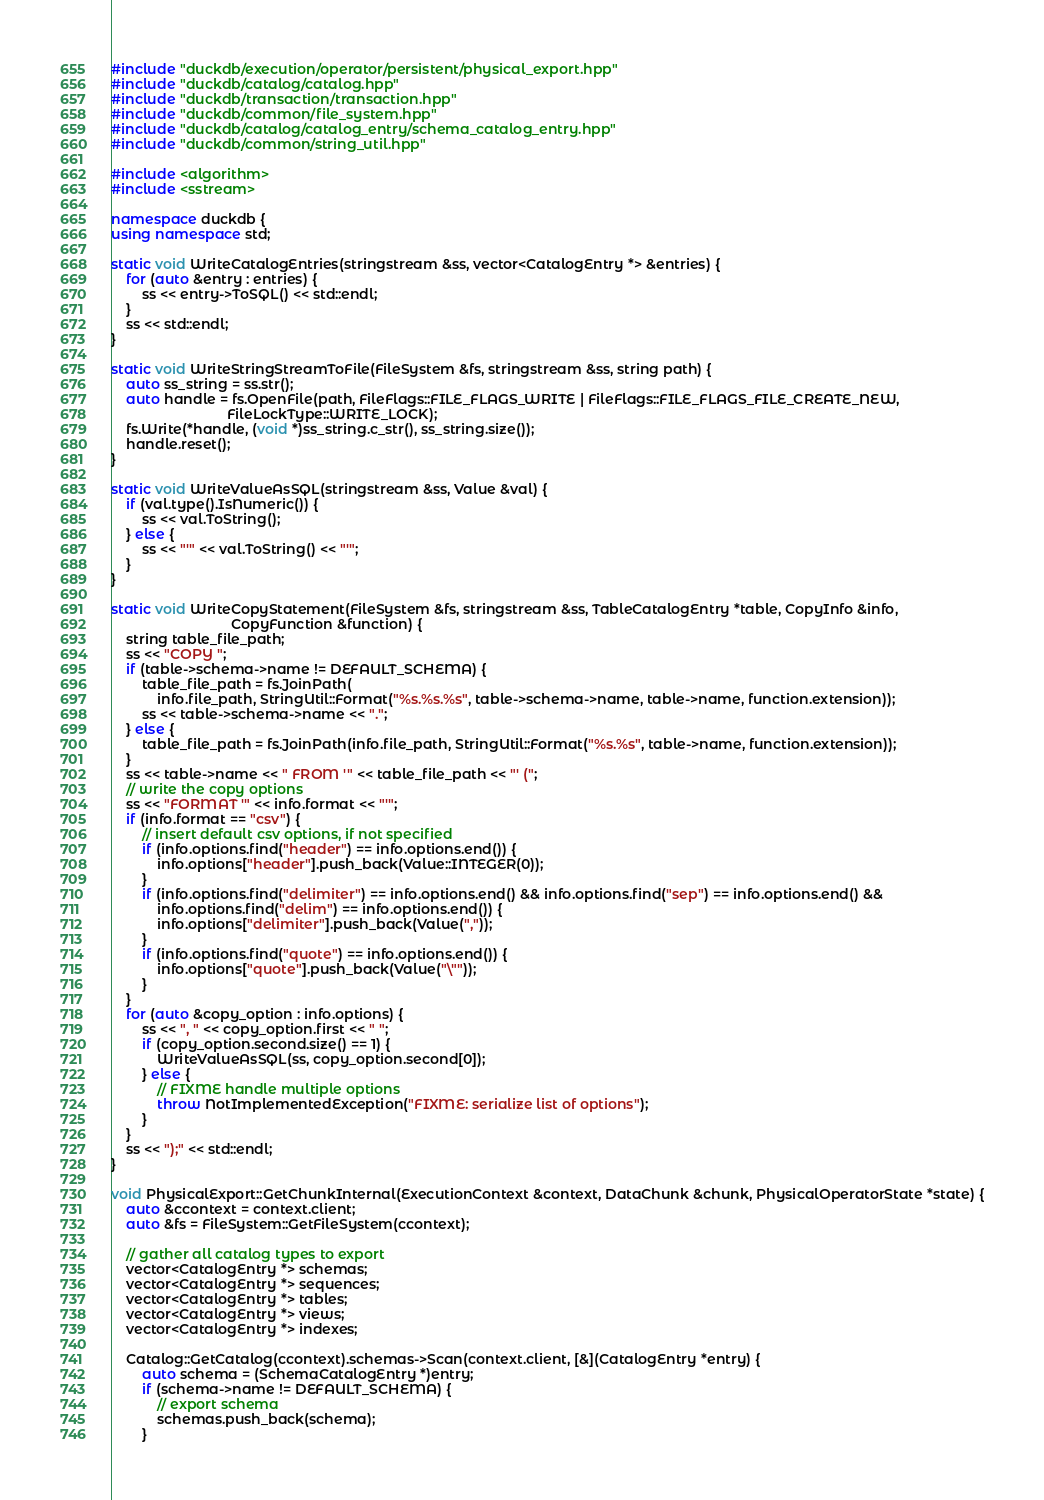Convert code to text. <code><loc_0><loc_0><loc_500><loc_500><_C++_>#include "duckdb/execution/operator/persistent/physical_export.hpp"
#include "duckdb/catalog/catalog.hpp"
#include "duckdb/transaction/transaction.hpp"
#include "duckdb/common/file_system.hpp"
#include "duckdb/catalog/catalog_entry/schema_catalog_entry.hpp"
#include "duckdb/common/string_util.hpp"

#include <algorithm>
#include <sstream>

namespace duckdb {
using namespace std;

static void WriteCatalogEntries(stringstream &ss, vector<CatalogEntry *> &entries) {
	for (auto &entry : entries) {
		ss << entry->ToSQL() << std::endl;
	}
	ss << std::endl;
}

static void WriteStringStreamToFile(FileSystem &fs, stringstream &ss, string path) {
	auto ss_string = ss.str();
	auto handle = fs.OpenFile(path, FileFlags::FILE_FLAGS_WRITE | FileFlags::FILE_FLAGS_FILE_CREATE_NEW,
	                          FileLockType::WRITE_LOCK);
	fs.Write(*handle, (void *)ss_string.c_str(), ss_string.size());
	handle.reset();
}

static void WriteValueAsSQL(stringstream &ss, Value &val) {
	if (val.type().IsNumeric()) {
		ss << val.ToString();
	} else {
		ss << "'" << val.ToString() << "'";
	}
}

static void WriteCopyStatement(FileSystem &fs, stringstream &ss, TableCatalogEntry *table, CopyInfo &info,
                               CopyFunction &function) {
	string table_file_path;
	ss << "COPY ";
	if (table->schema->name != DEFAULT_SCHEMA) {
		table_file_path = fs.JoinPath(
		    info.file_path, StringUtil::Format("%s.%s.%s", table->schema->name, table->name, function.extension));
		ss << table->schema->name << ".";
	} else {
		table_file_path = fs.JoinPath(info.file_path, StringUtil::Format("%s.%s", table->name, function.extension));
	}
	ss << table->name << " FROM '" << table_file_path << "' (";
	// write the copy options
	ss << "FORMAT '" << info.format << "'";
	if (info.format == "csv") {
		// insert default csv options, if not specified
		if (info.options.find("header") == info.options.end()) {
			info.options["header"].push_back(Value::INTEGER(0));
		}
		if (info.options.find("delimiter") == info.options.end() && info.options.find("sep") == info.options.end() &&
		    info.options.find("delim") == info.options.end()) {
			info.options["delimiter"].push_back(Value(","));
		}
		if (info.options.find("quote") == info.options.end()) {
			info.options["quote"].push_back(Value("\""));
		}
	}
	for (auto &copy_option : info.options) {
		ss << ", " << copy_option.first << " ";
		if (copy_option.second.size() == 1) {
			WriteValueAsSQL(ss, copy_option.second[0]);
		} else {
			// FIXME handle multiple options
			throw NotImplementedException("FIXME: serialize list of options");
		}
	}
	ss << ");" << std::endl;
}

void PhysicalExport::GetChunkInternal(ExecutionContext &context, DataChunk &chunk, PhysicalOperatorState *state) {
	auto &ccontext = context.client;
	auto &fs = FileSystem::GetFileSystem(ccontext);

	// gather all catalog types to export
	vector<CatalogEntry *> schemas;
	vector<CatalogEntry *> sequences;
	vector<CatalogEntry *> tables;
	vector<CatalogEntry *> views;
	vector<CatalogEntry *> indexes;

	Catalog::GetCatalog(ccontext).schemas->Scan(context.client, [&](CatalogEntry *entry) {
		auto schema = (SchemaCatalogEntry *)entry;
		if (schema->name != DEFAULT_SCHEMA) {
			// export schema
			schemas.push_back(schema);
		}</code> 